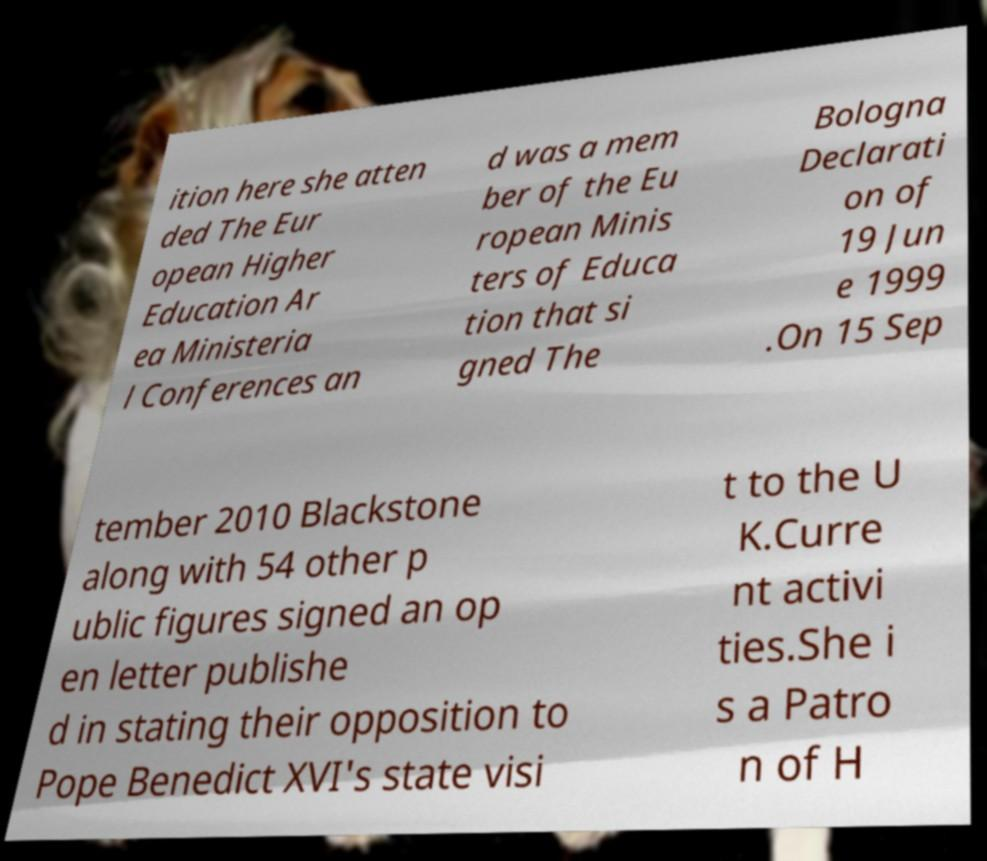Can you read and provide the text displayed in the image?This photo seems to have some interesting text. Can you extract and type it out for me? ition here she atten ded The Eur opean Higher Education Ar ea Ministeria l Conferences an d was a mem ber of the Eu ropean Minis ters of Educa tion that si gned The Bologna Declarati on of 19 Jun e 1999 .On 15 Sep tember 2010 Blackstone along with 54 other p ublic figures signed an op en letter publishe d in stating their opposition to Pope Benedict XVI's state visi t to the U K.Curre nt activi ties.She i s a Patro n of H 